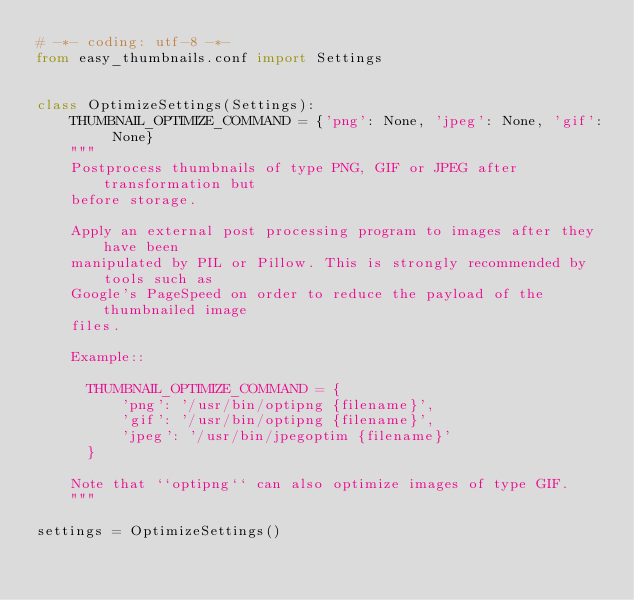<code> <loc_0><loc_0><loc_500><loc_500><_Python_># -*- coding: utf-8 -*-
from easy_thumbnails.conf import Settings


class OptimizeSettings(Settings):
    THUMBNAIL_OPTIMIZE_COMMAND = {'png': None, 'jpeg': None, 'gif': None}
    """
    Postprocess thumbnails of type PNG, GIF or JPEG after transformation but
    before storage.

    Apply an external post processing program to images after they have been
    manipulated by PIL or Pillow. This is strongly recommended by tools such as
    Google's PageSpeed on order to reduce the payload of the thumbnailed image
    files.

    Example::

      THUMBNAIL_OPTIMIZE_COMMAND = {
          'png': '/usr/bin/optipng {filename}',
          'gif': '/usr/bin/optipng {filename}',
          'jpeg': '/usr/bin/jpegoptim {filename}'
      }

    Note that ``optipng`` can also optimize images of type GIF.
    """

settings = OptimizeSettings()
</code> 